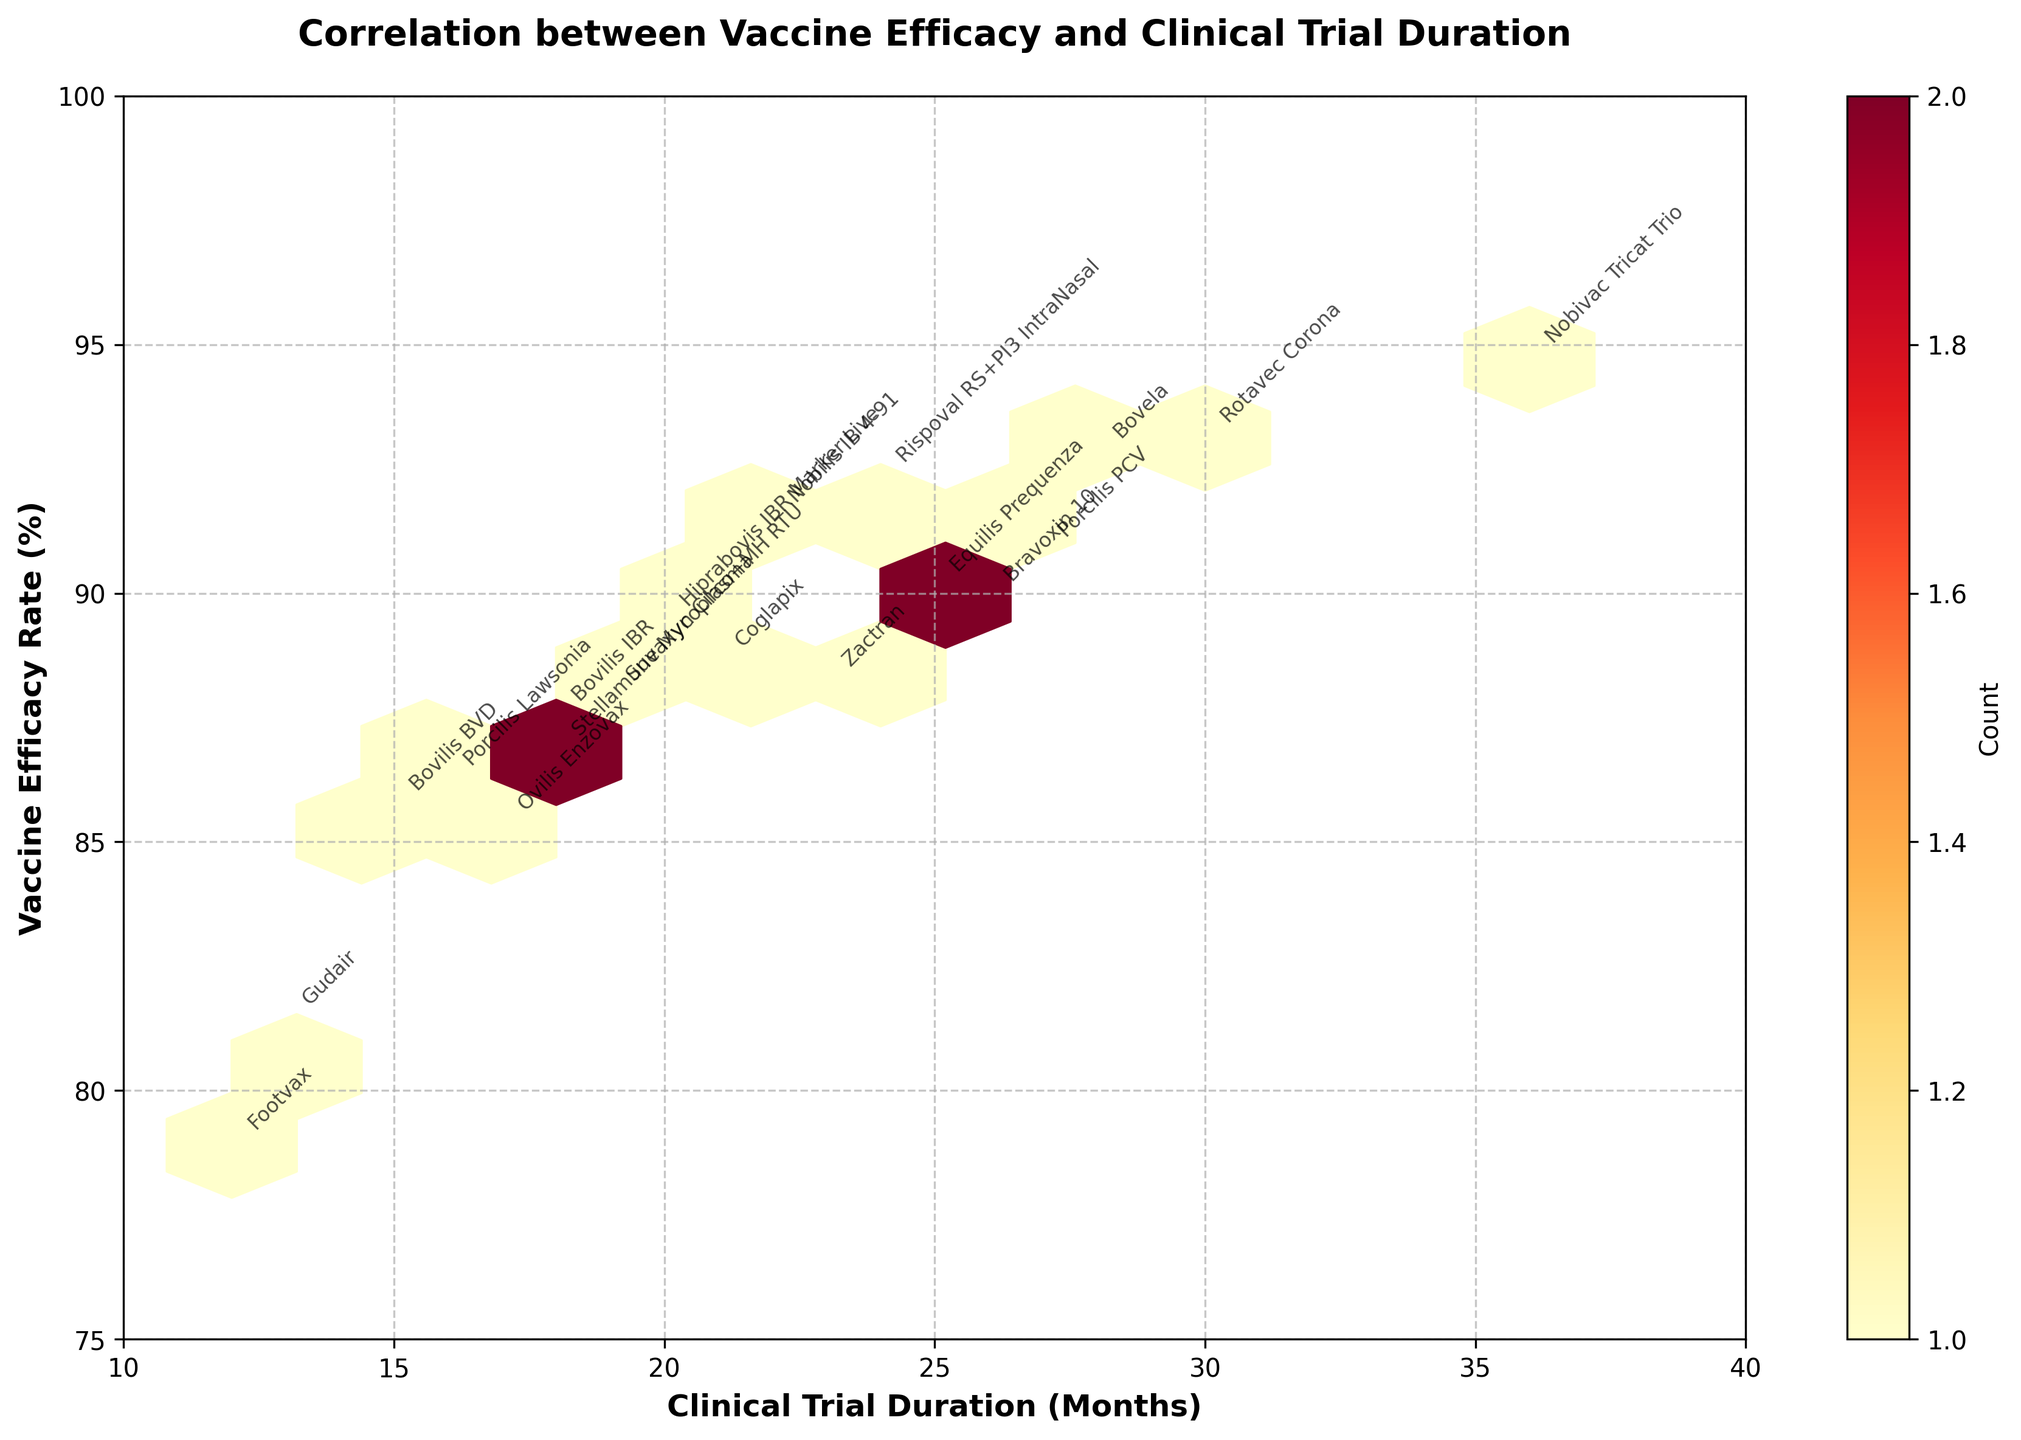What is the title of the figure? The title is usually displayed at the top of the figure to describe what it's about. From a quick look, it is evident in bold font.
Answer: Correlation between Vaccine Efficacy and Clinical Trial Duration What are the labels on the x-axis and y-axis? The labels on the axes describe what each axis represents, found typically at the ends of each axis.
Answer: Clinical Trial Duration (Months) for the x-axis and Vaccine Efficacy Rate (%) for the y-axis Which vaccine has the highest efficacy rate? By locating the highest y-value on the plot and checking the annotated label, you can determine the vaccine with the highest efficacy rate.
Answer: Nobivac Tricat Trio How many months was the clinical trial duration for Rotavec Corona? Find the point on the plot labeled "Rotavec Corona" and read its x-coordinate to determine the clinical trial duration in months.
Answer: 30 months What is the color indicating the highest density of data points on the plot? Hexbin plots use color intensity to represent the density of data points in a bin. The colormap 'YlOrRd' ranges from yellow (low density) to red (high density).
Answer: Red Are there more vaccines with efficacy rates above or below 90%? Count the number of data points above 90% on the y-axis and compare it with the number of data points below 90%.
Answer: Above 90% Which vaccine had the shortest clinical trial duration, and what was its efficacy rate? Look for the data point with the smallest x-coordinate and read the associated label and y-coordinate.
Answer: Footvax, with an efficacy rate of 78.9% Do vaccines with longer clinical trial durations generally have higher efficacy rates? Observe the trend where higher x-values (longer durations) correspond to higher y-values (efficacy rates).
Answer: Generally yes How many bins show the highest density according to the color bar? Check the number of hexagons colored red, as red indicates the highest density.
Answer: 1 What is the range of efficacy rates observed in the plot? Identify the lowest and highest y-values on the plot to determine the range of efficacy rates.
Answer: 78.9% to 94.7% 